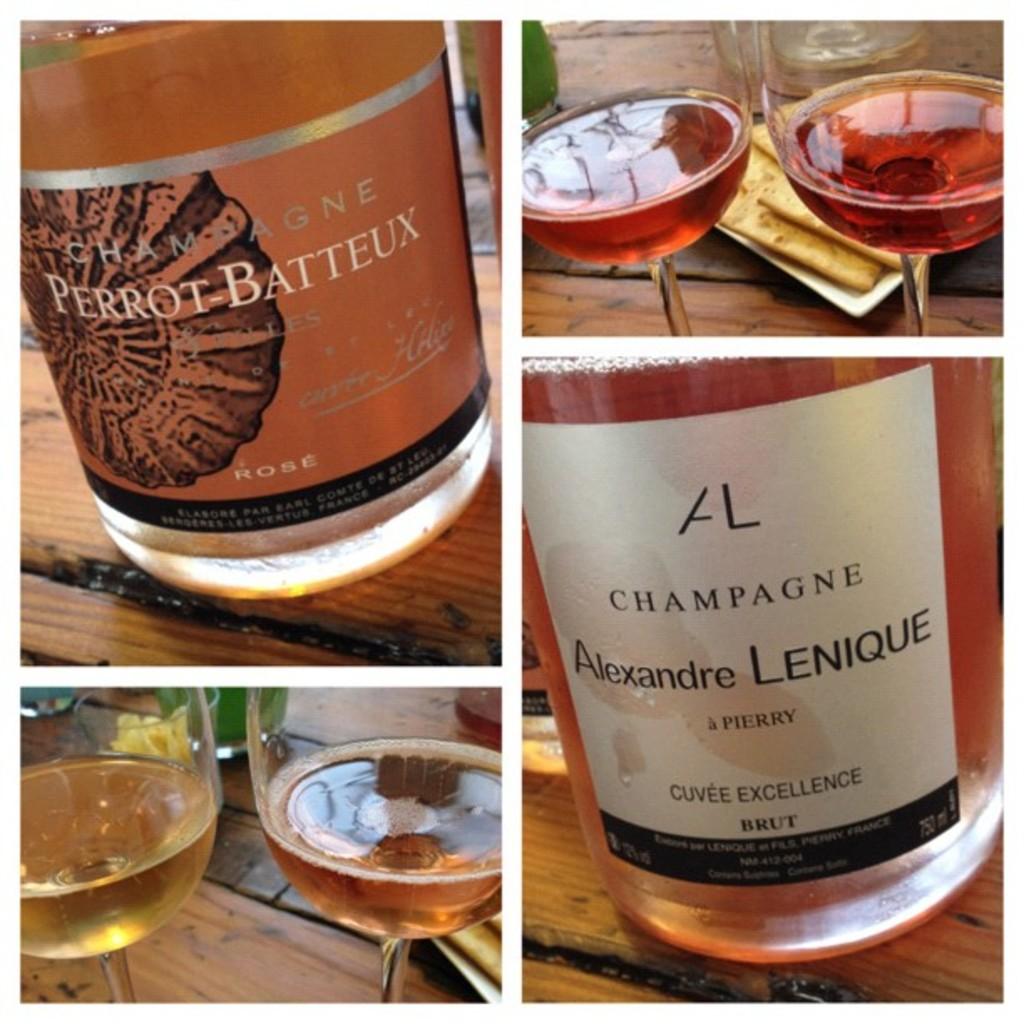What brand is this beverage?
Offer a very short reply. Alexandre lenique. 